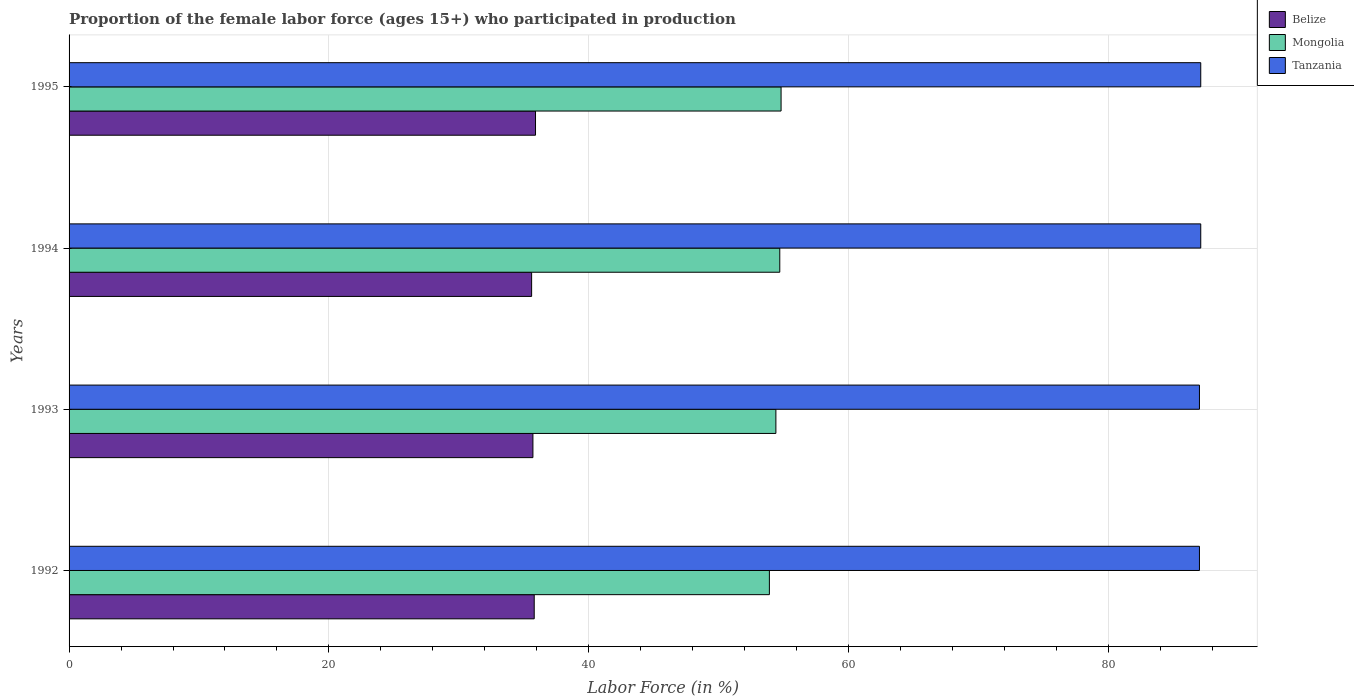How many different coloured bars are there?
Offer a terse response. 3. Are the number of bars per tick equal to the number of legend labels?
Offer a terse response. Yes. How many bars are there on the 3rd tick from the top?
Offer a terse response. 3. What is the label of the 3rd group of bars from the top?
Your answer should be compact. 1993. In how many cases, is the number of bars for a given year not equal to the number of legend labels?
Keep it short and to the point. 0. Across all years, what is the maximum proportion of the female labor force who participated in production in Belize?
Offer a terse response. 35.9. Across all years, what is the minimum proportion of the female labor force who participated in production in Mongolia?
Provide a succinct answer. 53.9. In which year was the proportion of the female labor force who participated in production in Belize maximum?
Give a very brief answer. 1995. What is the total proportion of the female labor force who participated in production in Tanzania in the graph?
Ensure brevity in your answer.  348.2. What is the difference between the proportion of the female labor force who participated in production in Mongolia in 1992 and that in 1993?
Your response must be concise. -0.5. What is the difference between the proportion of the female labor force who participated in production in Tanzania in 1992 and the proportion of the female labor force who participated in production in Mongolia in 1994?
Make the answer very short. 32.3. What is the average proportion of the female labor force who participated in production in Mongolia per year?
Offer a very short reply. 54.45. In the year 1993, what is the difference between the proportion of the female labor force who participated in production in Belize and proportion of the female labor force who participated in production in Mongolia?
Your response must be concise. -18.7. What is the ratio of the proportion of the female labor force who participated in production in Mongolia in 1992 to that in 1994?
Offer a terse response. 0.99. Is the proportion of the female labor force who participated in production in Tanzania in 1993 less than that in 1994?
Your answer should be compact. Yes. Is the difference between the proportion of the female labor force who participated in production in Belize in 1994 and 1995 greater than the difference between the proportion of the female labor force who participated in production in Mongolia in 1994 and 1995?
Ensure brevity in your answer.  No. What is the difference between the highest and the lowest proportion of the female labor force who participated in production in Mongolia?
Give a very brief answer. 0.9. Is the sum of the proportion of the female labor force who participated in production in Tanzania in 1992 and 1994 greater than the maximum proportion of the female labor force who participated in production in Mongolia across all years?
Offer a terse response. Yes. What does the 3rd bar from the top in 1995 represents?
Your response must be concise. Belize. What does the 3rd bar from the bottom in 1993 represents?
Make the answer very short. Tanzania. How many bars are there?
Ensure brevity in your answer.  12. How many years are there in the graph?
Your answer should be very brief. 4. Does the graph contain any zero values?
Make the answer very short. No. Does the graph contain grids?
Offer a terse response. Yes. How are the legend labels stacked?
Make the answer very short. Vertical. What is the title of the graph?
Provide a short and direct response. Proportion of the female labor force (ages 15+) who participated in production. Does "Liechtenstein" appear as one of the legend labels in the graph?
Offer a terse response. No. What is the label or title of the X-axis?
Give a very brief answer. Labor Force (in %). What is the Labor Force (in %) in Belize in 1992?
Ensure brevity in your answer.  35.8. What is the Labor Force (in %) in Mongolia in 1992?
Ensure brevity in your answer.  53.9. What is the Labor Force (in %) of Tanzania in 1992?
Keep it short and to the point. 87. What is the Labor Force (in %) of Belize in 1993?
Offer a terse response. 35.7. What is the Labor Force (in %) of Mongolia in 1993?
Your answer should be compact. 54.4. What is the Labor Force (in %) in Belize in 1994?
Provide a succinct answer. 35.6. What is the Labor Force (in %) of Mongolia in 1994?
Your response must be concise. 54.7. What is the Labor Force (in %) of Tanzania in 1994?
Provide a short and direct response. 87.1. What is the Labor Force (in %) in Belize in 1995?
Make the answer very short. 35.9. What is the Labor Force (in %) in Mongolia in 1995?
Your response must be concise. 54.8. What is the Labor Force (in %) in Tanzania in 1995?
Give a very brief answer. 87.1. Across all years, what is the maximum Labor Force (in %) in Belize?
Ensure brevity in your answer.  35.9. Across all years, what is the maximum Labor Force (in %) in Mongolia?
Provide a succinct answer. 54.8. Across all years, what is the maximum Labor Force (in %) in Tanzania?
Provide a succinct answer. 87.1. Across all years, what is the minimum Labor Force (in %) in Belize?
Keep it short and to the point. 35.6. Across all years, what is the minimum Labor Force (in %) in Mongolia?
Provide a short and direct response. 53.9. Across all years, what is the minimum Labor Force (in %) of Tanzania?
Offer a terse response. 87. What is the total Labor Force (in %) in Belize in the graph?
Offer a very short reply. 143. What is the total Labor Force (in %) in Mongolia in the graph?
Your answer should be very brief. 217.8. What is the total Labor Force (in %) in Tanzania in the graph?
Your response must be concise. 348.2. What is the difference between the Labor Force (in %) in Tanzania in 1992 and that in 1993?
Your response must be concise. 0. What is the difference between the Labor Force (in %) in Mongolia in 1992 and that in 1994?
Give a very brief answer. -0.8. What is the difference between the Labor Force (in %) in Tanzania in 1992 and that in 1994?
Keep it short and to the point. -0.1. What is the difference between the Labor Force (in %) in Mongolia in 1992 and that in 1995?
Give a very brief answer. -0.9. What is the difference between the Labor Force (in %) in Tanzania in 1992 and that in 1995?
Give a very brief answer. -0.1. What is the difference between the Labor Force (in %) in Belize in 1993 and that in 1994?
Keep it short and to the point. 0.1. What is the difference between the Labor Force (in %) in Mongolia in 1993 and that in 1994?
Provide a short and direct response. -0.3. What is the difference between the Labor Force (in %) in Belize in 1993 and that in 1995?
Give a very brief answer. -0.2. What is the difference between the Labor Force (in %) of Mongolia in 1994 and that in 1995?
Provide a short and direct response. -0.1. What is the difference between the Labor Force (in %) in Belize in 1992 and the Labor Force (in %) in Mongolia in 1993?
Your response must be concise. -18.6. What is the difference between the Labor Force (in %) of Belize in 1992 and the Labor Force (in %) of Tanzania in 1993?
Keep it short and to the point. -51.2. What is the difference between the Labor Force (in %) of Mongolia in 1992 and the Labor Force (in %) of Tanzania in 1993?
Offer a very short reply. -33.1. What is the difference between the Labor Force (in %) of Belize in 1992 and the Labor Force (in %) of Mongolia in 1994?
Your answer should be compact. -18.9. What is the difference between the Labor Force (in %) in Belize in 1992 and the Labor Force (in %) in Tanzania in 1994?
Your response must be concise. -51.3. What is the difference between the Labor Force (in %) in Mongolia in 1992 and the Labor Force (in %) in Tanzania in 1994?
Ensure brevity in your answer.  -33.2. What is the difference between the Labor Force (in %) of Belize in 1992 and the Labor Force (in %) of Tanzania in 1995?
Offer a terse response. -51.3. What is the difference between the Labor Force (in %) in Mongolia in 1992 and the Labor Force (in %) in Tanzania in 1995?
Give a very brief answer. -33.2. What is the difference between the Labor Force (in %) in Belize in 1993 and the Labor Force (in %) in Tanzania in 1994?
Your response must be concise. -51.4. What is the difference between the Labor Force (in %) in Mongolia in 1993 and the Labor Force (in %) in Tanzania in 1994?
Your response must be concise. -32.7. What is the difference between the Labor Force (in %) of Belize in 1993 and the Labor Force (in %) of Mongolia in 1995?
Offer a very short reply. -19.1. What is the difference between the Labor Force (in %) of Belize in 1993 and the Labor Force (in %) of Tanzania in 1995?
Offer a terse response. -51.4. What is the difference between the Labor Force (in %) of Mongolia in 1993 and the Labor Force (in %) of Tanzania in 1995?
Provide a succinct answer. -32.7. What is the difference between the Labor Force (in %) in Belize in 1994 and the Labor Force (in %) in Mongolia in 1995?
Your answer should be compact. -19.2. What is the difference between the Labor Force (in %) in Belize in 1994 and the Labor Force (in %) in Tanzania in 1995?
Offer a terse response. -51.5. What is the difference between the Labor Force (in %) in Mongolia in 1994 and the Labor Force (in %) in Tanzania in 1995?
Your answer should be very brief. -32.4. What is the average Labor Force (in %) in Belize per year?
Your answer should be compact. 35.75. What is the average Labor Force (in %) in Mongolia per year?
Your answer should be very brief. 54.45. What is the average Labor Force (in %) in Tanzania per year?
Provide a short and direct response. 87.05. In the year 1992, what is the difference between the Labor Force (in %) in Belize and Labor Force (in %) in Mongolia?
Make the answer very short. -18.1. In the year 1992, what is the difference between the Labor Force (in %) in Belize and Labor Force (in %) in Tanzania?
Offer a terse response. -51.2. In the year 1992, what is the difference between the Labor Force (in %) of Mongolia and Labor Force (in %) of Tanzania?
Provide a short and direct response. -33.1. In the year 1993, what is the difference between the Labor Force (in %) in Belize and Labor Force (in %) in Mongolia?
Your answer should be very brief. -18.7. In the year 1993, what is the difference between the Labor Force (in %) of Belize and Labor Force (in %) of Tanzania?
Provide a short and direct response. -51.3. In the year 1993, what is the difference between the Labor Force (in %) of Mongolia and Labor Force (in %) of Tanzania?
Your answer should be compact. -32.6. In the year 1994, what is the difference between the Labor Force (in %) in Belize and Labor Force (in %) in Mongolia?
Give a very brief answer. -19.1. In the year 1994, what is the difference between the Labor Force (in %) of Belize and Labor Force (in %) of Tanzania?
Provide a short and direct response. -51.5. In the year 1994, what is the difference between the Labor Force (in %) of Mongolia and Labor Force (in %) of Tanzania?
Give a very brief answer. -32.4. In the year 1995, what is the difference between the Labor Force (in %) of Belize and Labor Force (in %) of Mongolia?
Offer a terse response. -18.9. In the year 1995, what is the difference between the Labor Force (in %) of Belize and Labor Force (in %) of Tanzania?
Your answer should be very brief. -51.2. In the year 1995, what is the difference between the Labor Force (in %) of Mongolia and Labor Force (in %) of Tanzania?
Your response must be concise. -32.3. What is the ratio of the Labor Force (in %) in Belize in 1992 to that in 1993?
Your answer should be very brief. 1. What is the ratio of the Labor Force (in %) of Mongolia in 1992 to that in 1993?
Your response must be concise. 0.99. What is the ratio of the Labor Force (in %) in Tanzania in 1992 to that in 1993?
Ensure brevity in your answer.  1. What is the ratio of the Labor Force (in %) of Belize in 1992 to that in 1994?
Ensure brevity in your answer.  1.01. What is the ratio of the Labor Force (in %) in Mongolia in 1992 to that in 1994?
Provide a short and direct response. 0.99. What is the ratio of the Labor Force (in %) of Mongolia in 1992 to that in 1995?
Keep it short and to the point. 0.98. What is the ratio of the Labor Force (in %) in Belize in 1993 to that in 1994?
Provide a short and direct response. 1. What is the ratio of the Labor Force (in %) in Belize in 1993 to that in 1995?
Provide a succinct answer. 0.99. What is the ratio of the Labor Force (in %) in Tanzania in 1993 to that in 1995?
Ensure brevity in your answer.  1. What is the ratio of the Labor Force (in %) in Belize in 1994 to that in 1995?
Your response must be concise. 0.99. What is the difference between the highest and the second highest Labor Force (in %) in Mongolia?
Offer a very short reply. 0.1. What is the difference between the highest and the second highest Labor Force (in %) in Tanzania?
Offer a terse response. 0. What is the difference between the highest and the lowest Labor Force (in %) of Belize?
Offer a terse response. 0.3. What is the difference between the highest and the lowest Labor Force (in %) of Mongolia?
Provide a succinct answer. 0.9. What is the difference between the highest and the lowest Labor Force (in %) of Tanzania?
Your answer should be compact. 0.1. 